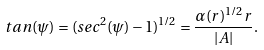<formula> <loc_0><loc_0><loc_500><loc_500>t a n ( \psi ) = ( s e c ^ { 2 } ( \psi ) - 1 ) ^ { 1 / 2 } = \frac { \alpha ( r ) ^ { 1 / 2 } r } { | A | } .</formula> 